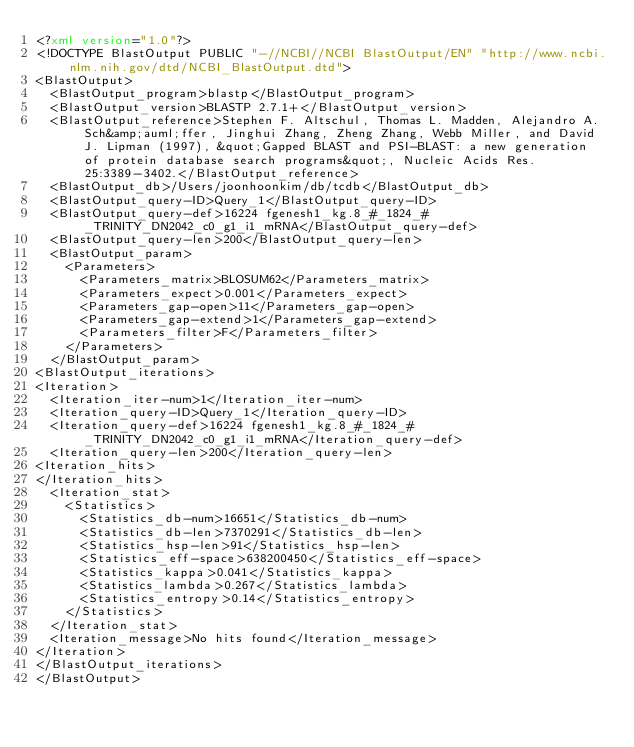<code> <loc_0><loc_0><loc_500><loc_500><_XML_><?xml version="1.0"?>
<!DOCTYPE BlastOutput PUBLIC "-//NCBI//NCBI BlastOutput/EN" "http://www.ncbi.nlm.nih.gov/dtd/NCBI_BlastOutput.dtd">
<BlastOutput>
  <BlastOutput_program>blastp</BlastOutput_program>
  <BlastOutput_version>BLASTP 2.7.1+</BlastOutput_version>
  <BlastOutput_reference>Stephen F. Altschul, Thomas L. Madden, Alejandro A. Sch&amp;auml;ffer, Jinghui Zhang, Zheng Zhang, Webb Miller, and David J. Lipman (1997), &quot;Gapped BLAST and PSI-BLAST: a new generation of protein database search programs&quot;, Nucleic Acids Res. 25:3389-3402.</BlastOutput_reference>
  <BlastOutput_db>/Users/joonhoonkim/db/tcdb</BlastOutput_db>
  <BlastOutput_query-ID>Query_1</BlastOutput_query-ID>
  <BlastOutput_query-def>16224 fgenesh1_kg.8_#_1824_#_TRINITY_DN2042_c0_g1_i1_mRNA</BlastOutput_query-def>
  <BlastOutput_query-len>200</BlastOutput_query-len>
  <BlastOutput_param>
    <Parameters>
      <Parameters_matrix>BLOSUM62</Parameters_matrix>
      <Parameters_expect>0.001</Parameters_expect>
      <Parameters_gap-open>11</Parameters_gap-open>
      <Parameters_gap-extend>1</Parameters_gap-extend>
      <Parameters_filter>F</Parameters_filter>
    </Parameters>
  </BlastOutput_param>
<BlastOutput_iterations>
<Iteration>
  <Iteration_iter-num>1</Iteration_iter-num>
  <Iteration_query-ID>Query_1</Iteration_query-ID>
  <Iteration_query-def>16224 fgenesh1_kg.8_#_1824_#_TRINITY_DN2042_c0_g1_i1_mRNA</Iteration_query-def>
  <Iteration_query-len>200</Iteration_query-len>
<Iteration_hits>
</Iteration_hits>
  <Iteration_stat>
    <Statistics>
      <Statistics_db-num>16651</Statistics_db-num>
      <Statistics_db-len>7370291</Statistics_db-len>
      <Statistics_hsp-len>91</Statistics_hsp-len>
      <Statistics_eff-space>638200450</Statistics_eff-space>
      <Statistics_kappa>0.041</Statistics_kappa>
      <Statistics_lambda>0.267</Statistics_lambda>
      <Statistics_entropy>0.14</Statistics_entropy>
    </Statistics>
  </Iteration_stat>
  <Iteration_message>No hits found</Iteration_message>
</Iteration>
</BlastOutput_iterations>
</BlastOutput>

</code> 